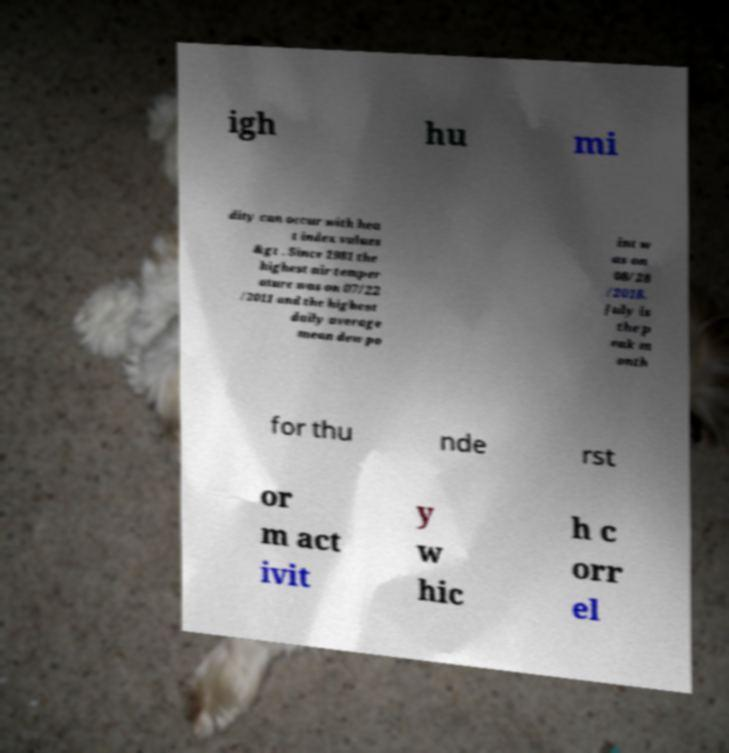Could you assist in decoding the text presented in this image and type it out clearly? igh hu mi dity can occur with hea t index values &gt . Since 1981 the highest air temper ature was on 07/22 /2011 and the highest daily average mean dew po int w as on 08/28 /2018. July is the p eak m onth for thu nde rst or m act ivit y w hic h c orr el 